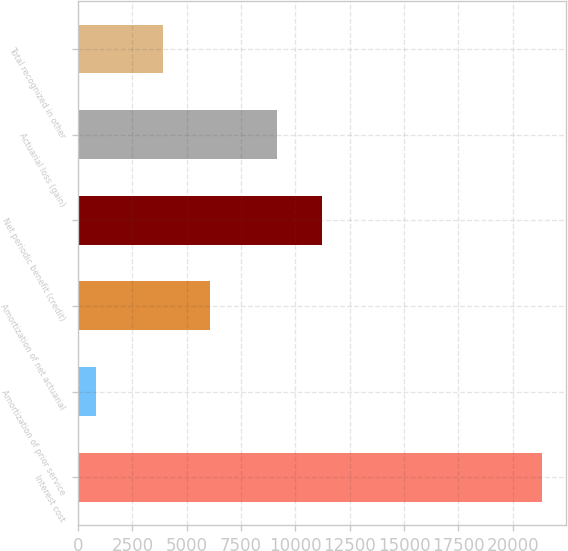Convert chart to OTSL. <chart><loc_0><loc_0><loc_500><loc_500><bar_chart><fcel>Interest cost<fcel>Amortization of prior service<fcel>Amortization of net actuarial<fcel>Net periodic benefit (credit)<fcel>Actuarial loss (gain)<fcel>Total recognized in other<nl><fcel>21364<fcel>801<fcel>6067<fcel>11207.3<fcel>9151<fcel>3885<nl></chart> 